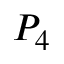<formula> <loc_0><loc_0><loc_500><loc_500>P _ { 4 }</formula> 